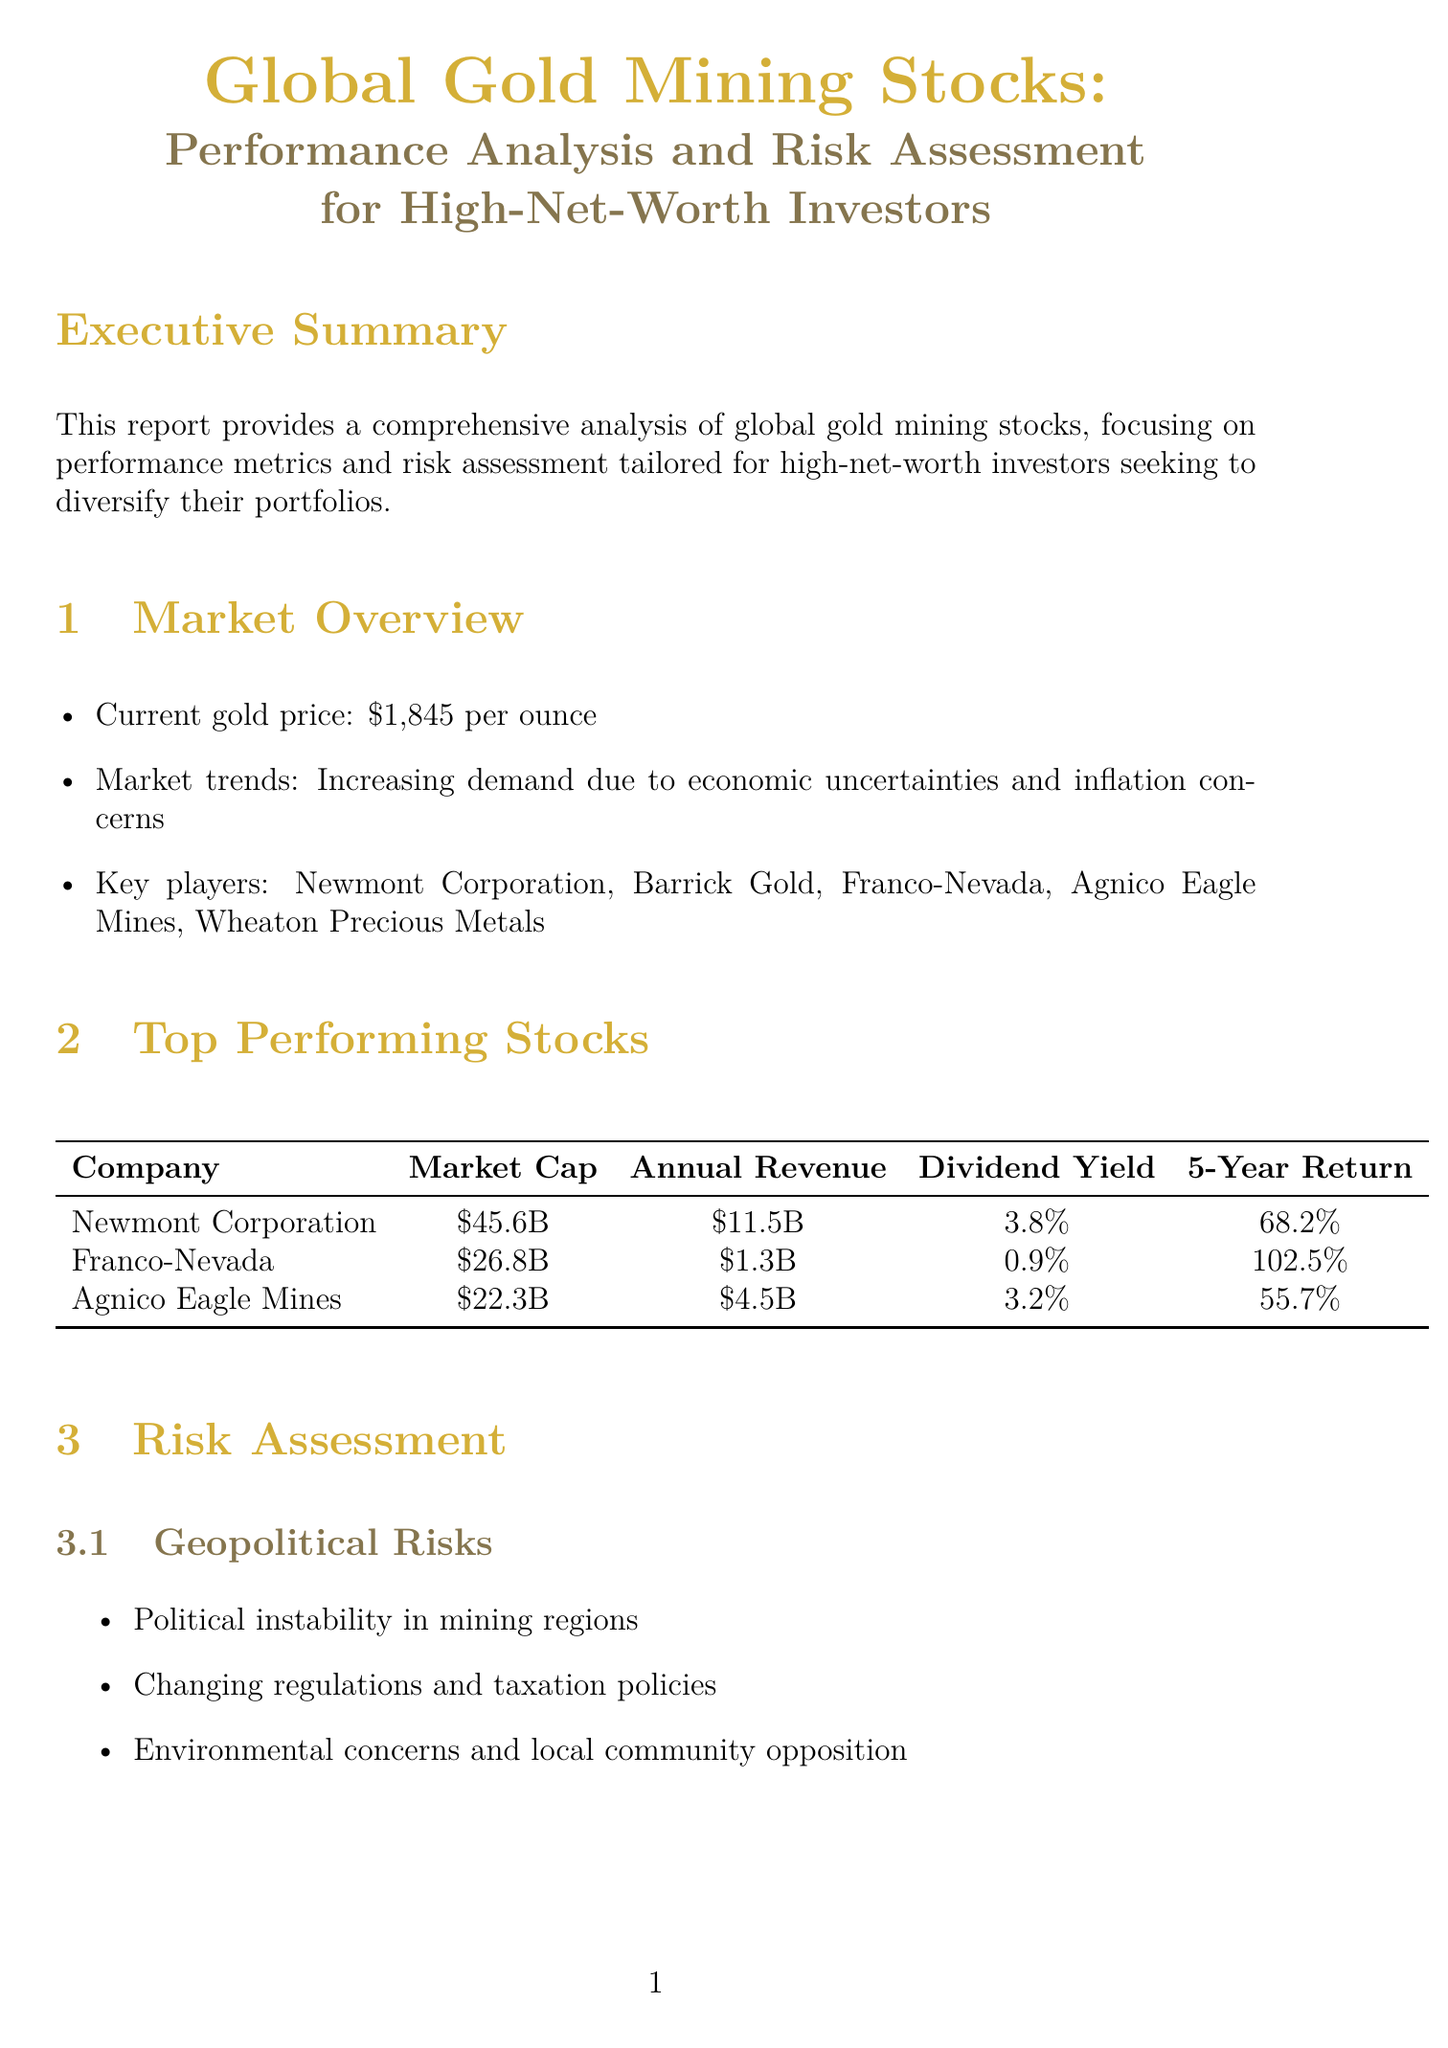What is the current gold price? The document states the current gold price as $1,845 per ounce.
Answer: $1,845 per ounce Who are the key players in the gold mining market? The document lists five key players in the gold mining market: Newmont Corporation, Barrick Gold, Franco-Nevada, Agnico Eagle Mines, and Wheaton Precious Metals.
Answer: Newmont Corporation, Barrick Gold, Franco-Nevada, Agnico Eagle Mines, Wheaton Precious Metals What is Franco-Nevada's 5-year return? The document provides Franco-Nevada's 5-year return as 102.5%.
Answer: 102.5% What risks are associated with gold mining investments? The document outlines several risks, including geopolitical risks, operational risks, and financial risks concerning gold mining investments.
Answer: Geopolitical, operational, financial Which investment strategy involves established, large-cap gold mining companies? The investment strategy mentioned in the document for established, large-cap companies is "Core Holdings."
Answer: Core Holdings What is the average P/E ratio in the gold mining industry? According to the document, the average P/E ratio in the gold mining industry is 22.5.
Answer: 22.5 What type of companies should investors focus on according to expert opinions? The experts suggest that investors should focus on companies with strong management teams, low-cost operations, and a history of navigating market cycles successfully.
Answer: Strong management teams What are some considerations for diversification in gold mining investments? The document lists geographical distribution of mining operations and exposure to other precious metals as considerations for diversification.
Answer: Geographical distribution, exposure to other precious metals 